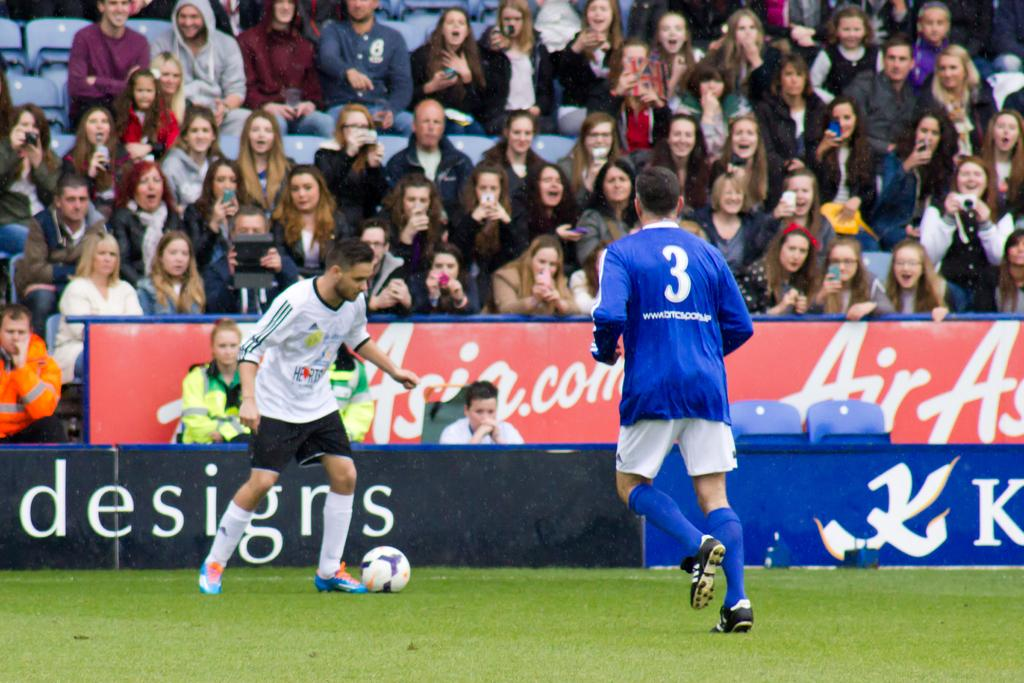How many people are present in the image? There are two persons in the image. What activity are the two persons engaged in? The two persons are playing football. Can you describe the setting of the image? There are spectators in the background of the image. What type of food is being served to the players during the game in the image? There is no food present in the image, and the players are not being served any food during the game. 